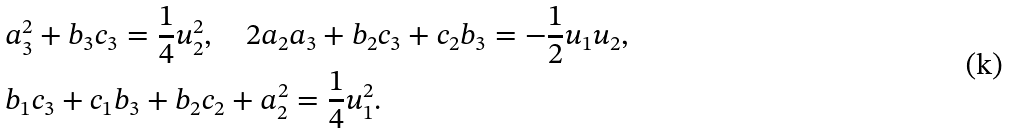Convert formula to latex. <formula><loc_0><loc_0><loc_500><loc_500>& a _ { 3 } ^ { 2 } + b _ { 3 } c _ { 3 } = \frac { 1 } { 4 } u _ { 2 } ^ { 2 } , \quad 2 a _ { 2 } a _ { 3 } + b _ { 2 } c _ { 3 } + c _ { 2 } b _ { 3 } = - \frac { 1 } { 2 } u _ { 1 } u _ { 2 } , \\ & b _ { 1 } c _ { 3 } + c _ { 1 } b _ { 3 } + b _ { 2 } c _ { 2 } + a _ { 2 } ^ { 2 } = \frac { 1 } { 4 } u _ { 1 } ^ { 2 } .</formula> 